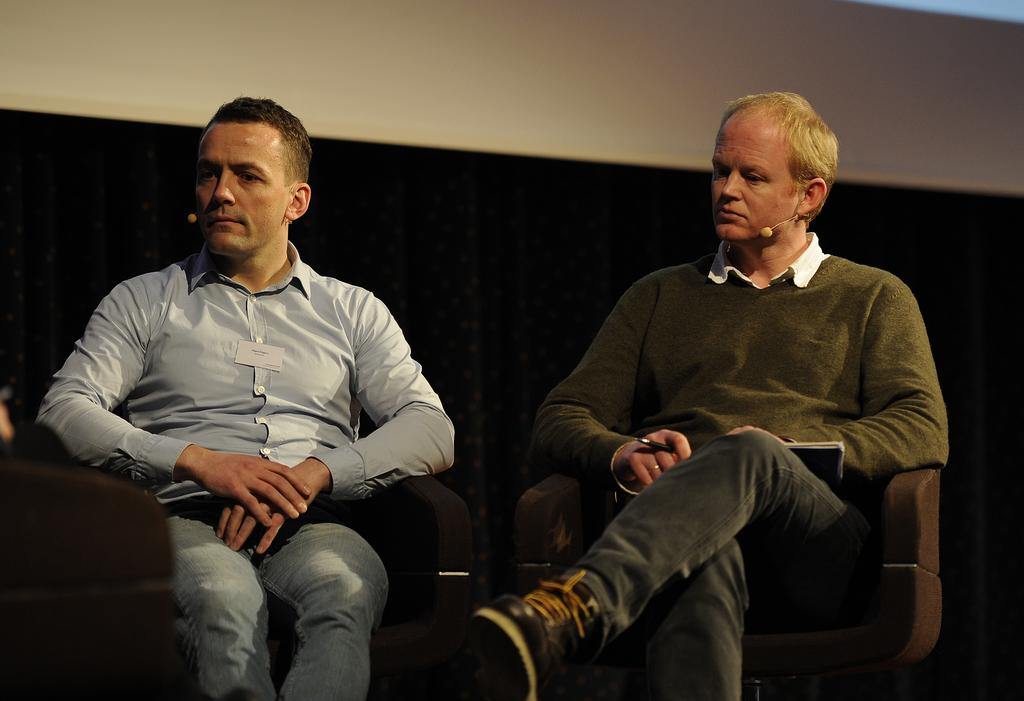How many people are sitting in the image? There are two people sitting on chairs in the image. What is one person holding in the image? One person is holding a pen. What object related to reading or learning is visible in the image? There is a book visible in the image. What can be seen in the background of the image? There is a wall in the background of the image. What type of tank is visible in the image? There is no tank present in the image. How many verses are written on the mailbox in the image? There is no mailbox or verses present in the image. 